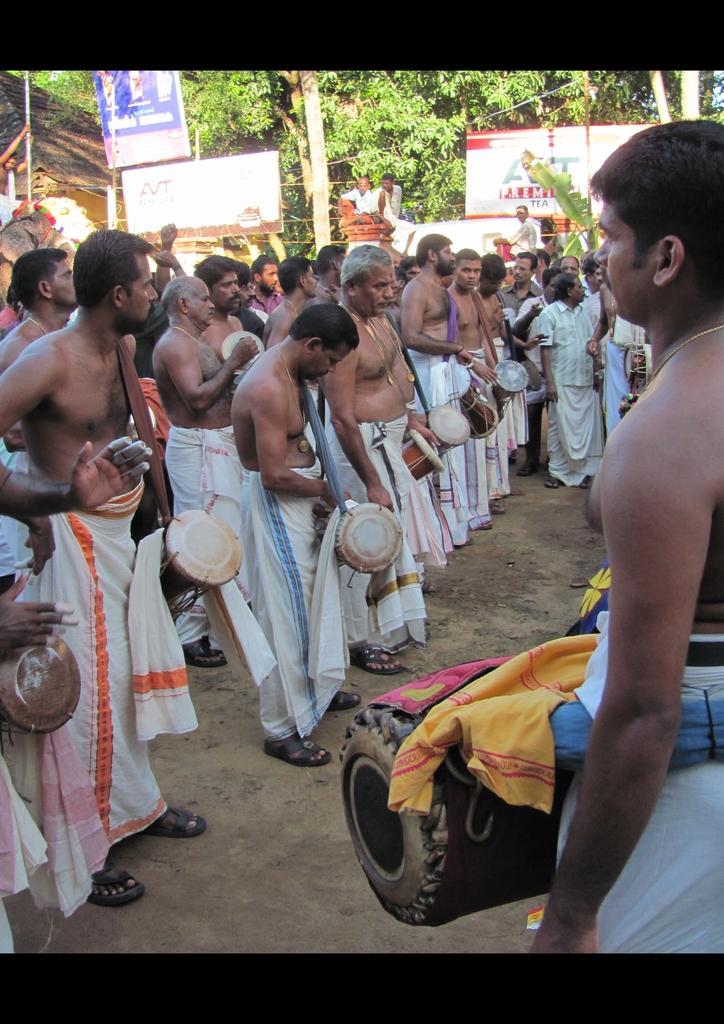Describe this image in one or two sentences. Here we can see a group of people Standing and playing drums and behind them we can see trees and banners present 